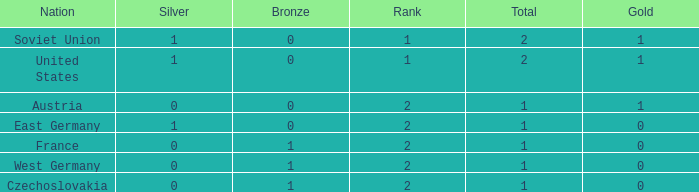What is the rank of the team with 0 gold and less than 0 silvers? None. 